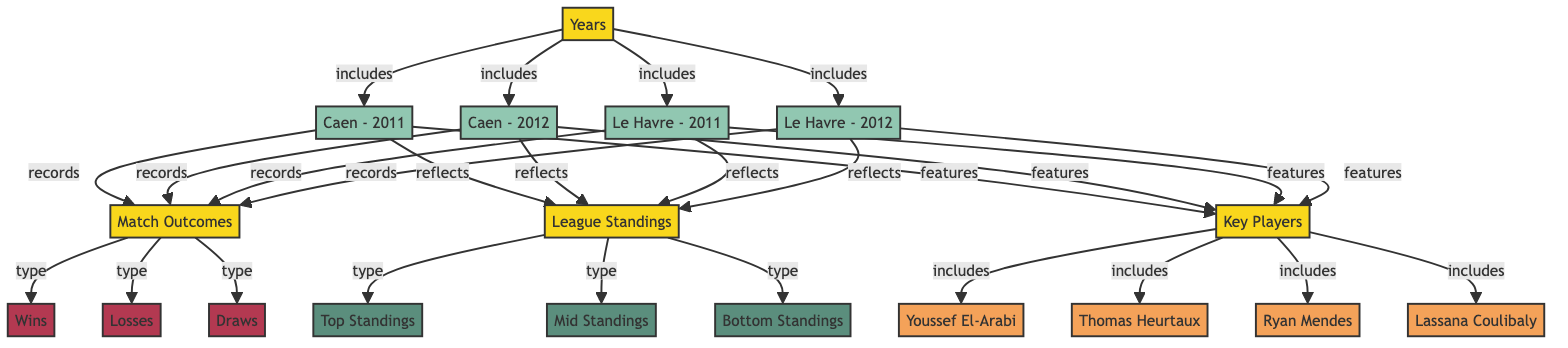What teams are represented in the diagram? The diagram includes teams from Caen and Le Havre, specifically from the years 2011 and 2012. Therefore, the teams are Caen and Le Havre.
Answer: Caen, Le Havre How many match outcomes categories are included in the diagram? The diagram has three categories under match outcomes: Wins, Losses, and Draws. Counting these gives us three categories.
Answer: 3 Which player is associated with Caen in the diagram? Among the players listed, Youssef El-Arabi, Thomas Heurtaux, Ryan Mendes, and Lassana Coulibaly are included, but the relationship indicates that they are all featured for both teams. Hence, there isn’t a single player exclusive to Caen.
Answer: Multiple players What reflects the league standings for Le Havre in 2012? The reflection for league standings is categorized under Mid Standings. Since Le Havre's data is labeled, we identify Mid Standings as the related node.
Answer: Mid Standings What are the match outcomes recorded for Caen in 2011? The categories for match outcomes are Wins, Losses, and Draws, but the specific records are not detailed in the diagram. We conclude that all three categories apply to Caen in 2011.
Answer: All outcomes Which team has data for both years in the diagram? Both Caen and Le Havre have their data represented for the years 2011 and 2012, indicating they are the teams with records for both years.
Answer: Caen, Le Havre What is the relationship between match outcomes and league standings? Match outcomes reflect the league standings, meaning the success of wins and losses contributes to the overall standing in the league. This is a direct indication of how match performance affects positioning.
Answer: Reflects Which key player is linked to Le Havre? All listed players, including Youssef El-Arabi, Thomas Heurtaux, Ryan Mendes, and Lassana Coulibaly, are linked to both teams; thus, all are potential key players for Le Havre.
Answer: Multiple players 